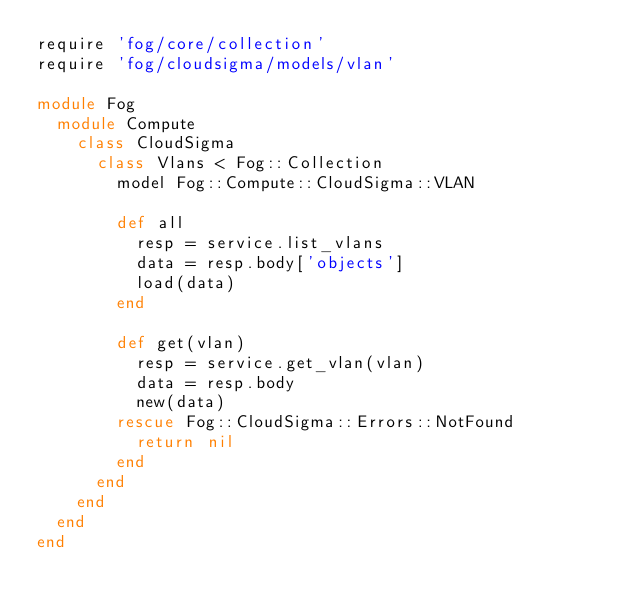Convert code to text. <code><loc_0><loc_0><loc_500><loc_500><_Ruby_>require 'fog/core/collection'
require 'fog/cloudsigma/models/vlan'

module Fog
  module Compute
    class CloudSigma
      class Vlans < Fog::Collection
        model Fog::Compute::CloudSigma::VLAN

        def all
          resp = service.list_vlans
          data = resp.body['objects']
          load(data)
        end

        def get(vlan)
          resp = service.get_vlan(vlan)
          data = resp.body
          new(data)
        rescue Fog::CloudSigma::Errors::NotFound
          return nil
        end
      end
    end
  end
end
</code> 